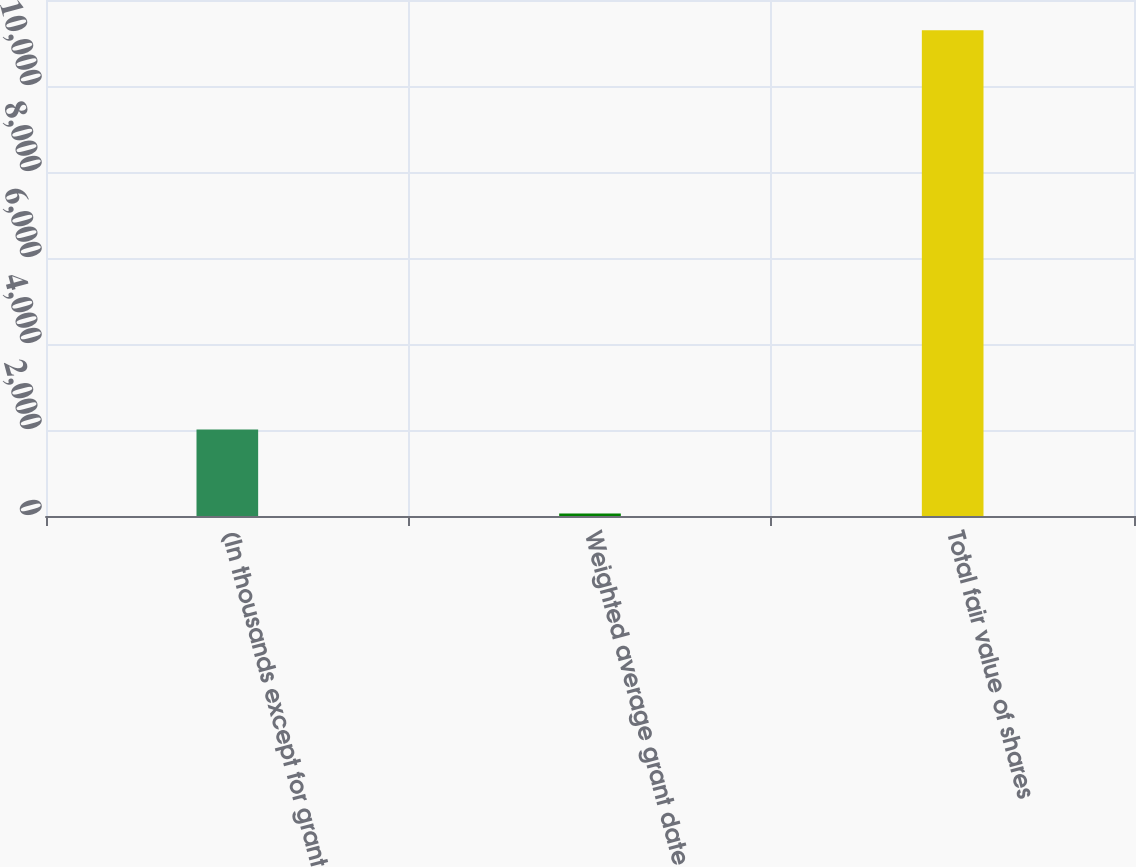Convert chart to OTSL. <chart><loc_0><loc_0><loc_500><loc_500><bar_chart><fcel>(In thousands except for grant<fcel>Weighted average grant date<fcel>Total fair value of shares<nl><fcel>2014<fcel>55.27<fcel>11294<nl></chart> 